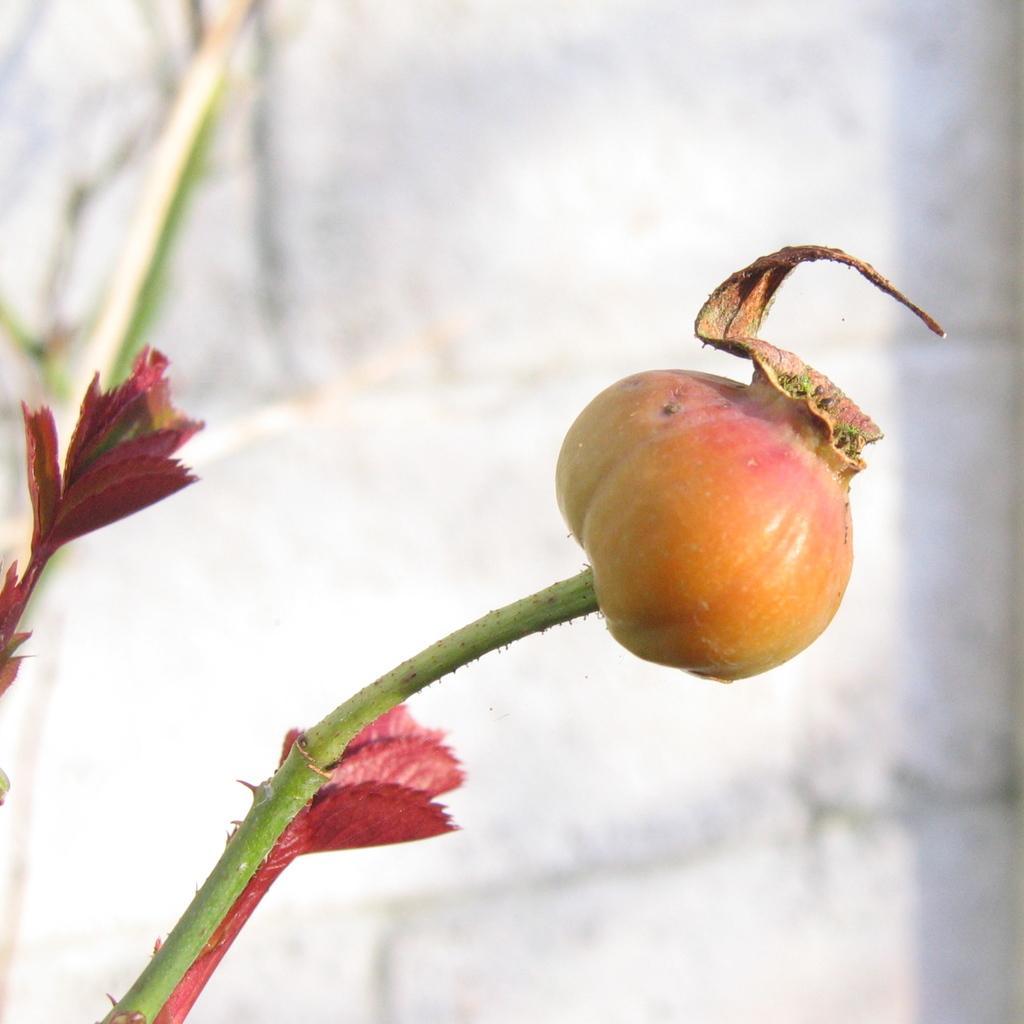Describe this image in one or two sentences. In the foreground of this image, there is a rose hip to the stem and in the background, we can see few red colored leafs and the wall. 